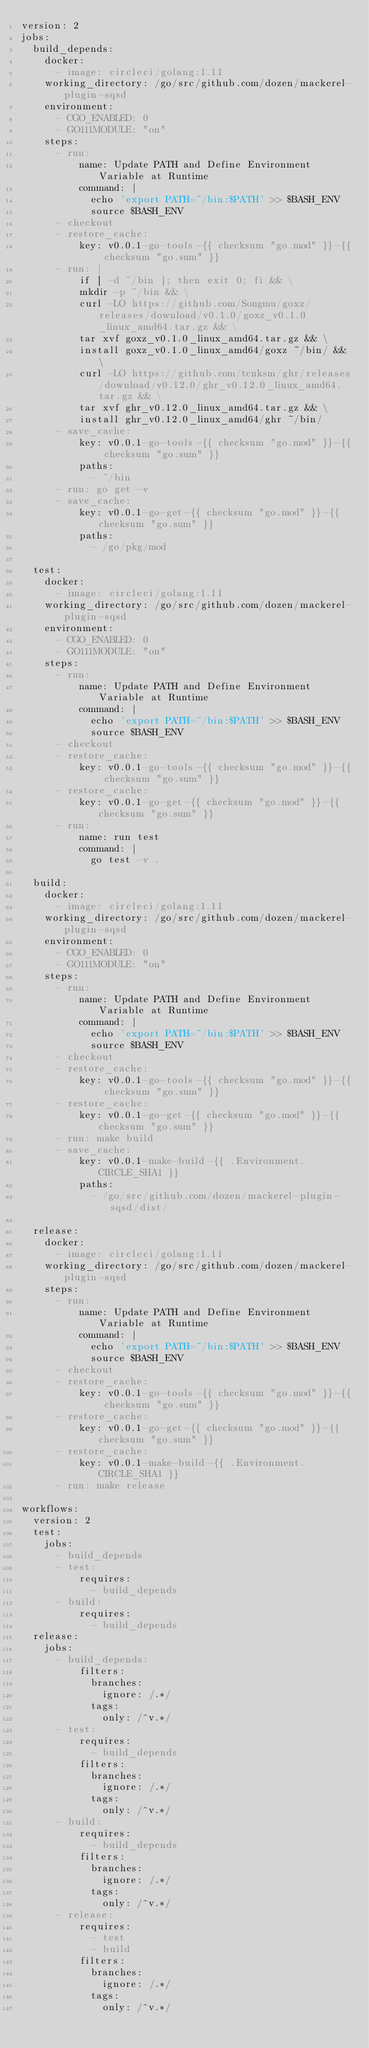<code> <loc_0><loc_0><loc_500><loc_500><_YAML_>version: 2
jobs:
  build_depends:
    docker:
      - image: circleci/golang:1.11
    working_directory: /go/src/github.com/dozen/mackerel-plugin-sqsd
    environment:
      - CGO_ENABLED: 0
      - GO111MODULE: "on"
    steps:
      - run:
          name: Update PATH and Define Environment Variable at Runtime
          command: |
            echo 'export PATH=~/bin:$PATH' >> $BASH_ENV
            source $BASH_ENV
      - checkout
      - restore_cache:
          key: v0.0.1-go-tools-{{ checksum "go.mod" }}-{{ checksum "go.sum" }}
      - run: |
          if [ -d ~/bin ]; then exit 0; fi && \
          mkdir -p ~/bin && \
          curl -LO https://github.com/Songmu/goxz/releases/download/v0.1.0/goxz_v0.1.0_linux_amd64.tar.gz && \
          tar xvf goxz_v0.1.0_linux_amd64.tar.gz && \
          install goxz_v0.1.0_linux_amd64/goxz ~/bin/ && \
          curl -LO https://github.com/tcnksm/ghr/releases/download/v0.12.0/ghr_v0.12.0_linux_amd64.tar.gz && \
          tar xvf ghr_v0.12.0_linux_amd64.tar.gz && \
          install ghr_v0.12.0_linux_amd64/ghr ~/bin/
      - save_cache:
          key: v0.0.1-go-tools-{{ checksum "go.mod" }}-{{ checksum "go.sum" }}
          paths:
            - ~/bin
      - run: go get -v
      - save_cache:
          key: v0.0.1-go-get-{{ checksum "go.mod" }}-{{ checksum "go.sum" }}
          paths:
            - /go/pkg/mod

  test:
    docker:
      - image: circleci/golang:1.11
    working_directory: /go/src/github.com/dozen/mackerel-plugin-sqsd
    environment:
      - CGO_ENABLED: 0
      - GO111MODULE: "on"
    steps:
      - run:
          name: Update PATH and Define Environment Variable at Runtime
          command: |
            echo 'export PATH=~/bin:$PATH' >> $BASH_ENV
            source $BASH_ENV
      - checkout
      - restore_cache:
          key: v0.0.1-go-tools-{{ checksum "go.mod" }}-{{ checksum "go.sum" }}
      - restore_cache:
          key: v0.0.1-go-get-{{ checksum "go.mod" }}-{{ checksum "go.sum" }}
      - run:
          name: run test
          command: |
            go test -v .

  build:
    docker:
      - image: circleci/golang:1.11
    working_directory: /go/src/github.com/dozen/mackerel-plugin-sqsd
    environment:
      - CGO_ENABLED: 0
      - GO111MODULE: "on"
    steps:
      - run:
          name: Update PATH and Define Environment Variable at Runtime
          command: |
            echo 'export PATH=~/bin:$PATH' >> $BASH_ENV
            source $BASH_ENV
      - checkout
      - restore_cache:
          key: v0.0.1-go-tools-{{ checksum "go.mod" }}-{{ checksum "go.sum" }}
      - restore_cache:
          key: v0.0.1-go-get-{{ checksum "go.mod" }}-{{ checksum "go.sum" }}
      - run: make build
      - save_cache:
          key: v0.0.1-make-build-{{ .Environment.CIRCLE_SHA1 }}
          paths:
            - /go/src/github.com/dozen/mackerel-plugin-sqsd/dist/

  release:
    docker:
      - image: circleci/golang:1.11
    working_directory: /go/src/github.com/dozen/mackerel-plugin-sqsd
    steps:
      - run:
          name: Update PATH and Define Environment Variable at Runtime
          command: |
            echo 'export PATH=~/bin:$PATH' >> $BASH_ENV
            source $BASH_ENV
      - checkout
      - restore_cache:
          key: v0.0.1-go-tools-{{ checksum "go.mod" }}-{{ checksum "go.sum" }}
      - restore_cache:
          key: v0.0.1-go-get-{{ checksum "go.mod" }}-{{ checksum "go.sum" }}
      - restore_cache:
          key: v0.0.1-make-build-{{ .Environment.CIRCLE_SHA1 }}
      - run: make release

workflows:
  version: 2
  test:
    jobs:
      - build_depends
      - test:
          requires:
            - build_depends
      - build:
          requires:
            - build_depends
  release:
    jobs:
      - build_depends:
          filters:
            branches:
              ignore: /.*/
            tags:
              only: /^v.*/
      - test:
          requires:
            - build_depends
          filters:
            branches:
              ignore: /.*/
            tags:
              only: /^v.*/
      - build:
          requires:
            - build_depends
          filters:
            branches:
              ignore: /.*/
            tags:
              only: /^v.*/
      - release:
          requires:
            - test
            - build
          filters:
            branches:
              ignore: /.*/
            tags:
              only: /^v.*/
</code> 